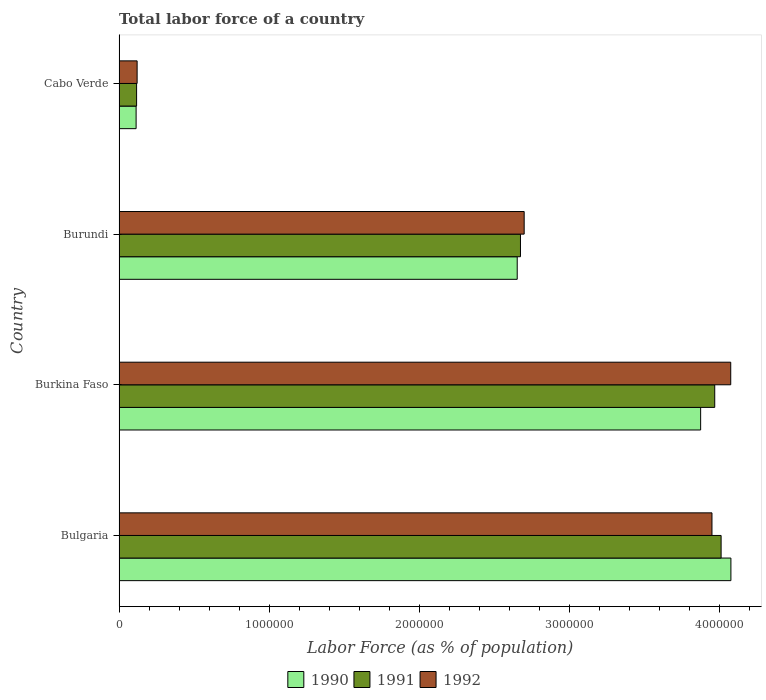How many bars are there on the 4th tick from the top?
Your answer should be compact. 3. How many bars are there on the 4th tick from the bottom?
Give a very brief answer. 3. What is the label of the 1st group of bars from the top?
Ensure brevity in your answer.  Cabo Verde. In how many cases, is the number of bars for a given country not equal to the number of legend labels?
Keep it short and to the point. 0. What is the percentage of labor force in 1991 in Burundi?
Your answer should be compact. 2.68e+06. Across all countries, what is the maximum percentage of labor force in 1991?
Provide a succinct answer. 4.01e+06. Across all countries, what is the minimum percentage of labor force in 1991?
Provide a succinct answer. 1.17e+05. In which country was the percentage of labor force in 1990 minimum?
Give a very brief answer. Cabo Verde. What is the total percentage of labor force in 1992 in the graph?
Keep it short and to the point. 1.08e+07. What is the difference between the percentage of labor force in 1992 in Burkina Faso and that in Burundi?
Your answer should be compact. 1.38e+06. What is the difference between the percentage of labor force in 1990 in Burundi and the percentage of labor force in 1991 in Bulgaria?
Offer a terse response. -1.36e+06. What is the average percentage of labor force in 1992 per country?
Ensure brevity in your answer.  2.71e+06. What is the difference between the percentage of labor force in 1990 and percentage of labor force in 1991 in Bulgaria?
Your answer should be compact. 6.53e+04. In how many countries, is the percentage of labor force in 1990 greater than 3000000 %?
Offer a terse response. 2. What is the ratio of the percentage of labor force in 1992 in Burkina Faso to that in Burundi?
Your answer should be compact. 1.51. What is the difference between the highest and the second highest percentage of labor force in 1992?
Make the answer very short. 1.25e+05. What is the difference between the highest and the lowest percentage of labor force in 1992?
Your answer should be very brief. 3.96e+06. In how many countries, is the percentage of labor force in 1992 greater than the average percentage of labor force in 1992 taken over all countries?
Your answer should be compact. 2. Is the sum of the percentage of labor force in 1991 in Bulgaria and Burundi greater than the maximum percentage of labor force in 1992 across all countries?
Your response must be concise. Yes. What does the 3rd bar from the bottom in Burkina Faso represents?
Offer a very short reply. 1992. How many countries are there in the graph?
Your answer should be very brief. 4. Are the values on the major ticks of X-axis written in scientific E-notation?
Ensure brevity in your answer.  No. Does the graph contain any zero values?
Ensure brevity in your answer.  No. Does the graph contain grids?
Offer a terse response. No. How many legend labels are there?
Your response must be concise. 3. What is the title of the graph?
Make the answer very short. Total labor force of a country. Does "1984" appear as one of the legend labels in the graph?
Keep it short and to the point. No. What is the label or title of the X-axis?
Offer a very short reply. Labor Force (as % of population). What is the Labor Force (as % of population) in 1990 in Bulgaria?
Make the answer very short. 4.08e+06. What is the Labor Force (as % of population) in 1991 in Bulgaria?
Ensure brevity in your answer.  4.01e+06. What is the Labor Force (as % of population) of 1992 in Bulgaria?
Ensure brevity in your answer.  3.95e+06. What is the Labor Force (as % of population) of 1990 in Burkina Faso?
Your answer should be very brief. 3.88e+06. What is the Labor Force (as % of population) in 1991 in Burkina Faso?
Your response must be concise. 3.97e+06. What is the Labor Force (as % of population) in 1992 in Burkina Faso?
Offer a terse response. 4.08e+06. What is the Labor Force (as % of population) of 1990 in Burundi?
Give a very brief answer. 2.65e+06. What is the Labor Force (as % of population) of 1991 in Burundi?
Offer a terse response. 2.68e+06. What is the Labor Force (as % of population) in 1992 in Burundi?
Make the answer very short. 2.70e+06. What is the Labor Force (as % of population) of 1990 in Cabo Verde?
Keep it short and to the point. 1.14e+05. What is the Labor Force (as % of population) in 1991 in Cabo Verde?
Provide a short and direct response. 1.17e+05. What is the Labor Force (as % of population) of 1992 in Cabo Verde?
Offer a terse response. 1.20e+05. Across all countries, what is the maximum Labor Force (as % of population) of 1990?
Provide a succinct answer. 4.08e+06. Across all countries, what is the maximum Labor Force (as % of population) in 1991?
Make the answer very short. 4.01e+06. Across all countries, what is the maximum Labor Force (as % of population) of 1992?
Give a very brief answer. 4.08e+06. Across all countries, what is the minimum Labor Force (as % of population) of 1990?
Offer a very short reply. 1.14e+05. Across all countries, what is the minimum Labor Force (as % of population) in 1991?
Make the answer very short. 1.17e+05. Across all countries, what is the minimum Labor Force (as % of population) of 1992?
Offer a terse response. 1.20e+05. What is the total Labor Force (as % of population) of 1990 in the graph?
Your answer should be compact. 1.07e+07. What is the total Labor Force (as % of population) in 1991 in the graph?
Your response must be concise. 1.08e+07. What is the total Labor Force (as % of population) of 1992 in the graph?
Your answer should be compact. 1.08e+07. What is the difference between the Labor Force (as % of population) in 1990 in Bulgaria and that in Burkina Faso?
Offer a terse response. 2.02e+05. What is the difference between the Labor Force (as % of population) in 1991 in Bulgaria and that in Burkina Faso?
Provide a succinct answer. 4.25e+04. What is the difference between the Labor Force (as % of population) of 1992 in Bulgaria and that in Burkina Faso?
Keep it short and to the point. -1.25e+05. What is the difference between the Labor Force (as % of population) in 1990 in Bulgaria and that in Burundi?
Your answer should be very brief. 1.42e+06. What is the difference between the Labor Force (as % of population) of 1991 in Bulgaria and that in Burundi?
Provide a short and direct response. 1.34e+06. What is the difference between the Labor Force (as % of population) of 1992 in Bulgaria and that in Burundi?
Provide a succinct answer. 1.25e+06. What is the difference between the Labor Force (as % of population) of 1990 in Bulgaria and that in Cabo Verde?
Keep it short and to the point. 3.96e+06. What is the difference between the Labor Force (as % of population) of 1991 in Bulgaria and that in Cabo Verde?
Provide a succinct answer. 3.90e+06. What is the difference between the Labor Force (as % of population) in 1992 in Bulgaria and that in Cabo Verde?
Give a very brief answer. 3.83e+06. What is the difference between the Labor Force (as % of population) of 1990 in Burkina Faso and that in Burundi?
Your answer should be very brief. 1.22e+06. What is the difference between the Labor Force (as % of population) of 1991 in Burkina Faso and that in Burundi?
Make the answer very short. 1.29e+06. What is the difference between the Labor Force (as % of population) in 1992 in Burkina Faso and that in Burundi?
Make the answer very short. 1.38e+06. What is the difference between the Labor Force (as % of population) in 1990 in Burkina Faso and that in Cabo Verde?
Your answer should be compact. 3.76e+06. What is the difference between the Labor Force (as % of population) in 1991 in Burkina Faso and that in Cabo Verde?
Ensure brevity in your answer.  3.85e+06. What is the difference between the Labor Force (as % of population) of 1992 in Burkina Faso and that in Cabo Verde?
Your answer should be compact. 3.96e+06. What is the difference between the Labor Force (as % of population) in 1990 in Burundi and that in Cabo Verde?
Give a very brief answer. 2.54e+06. What is the difference between the Labor Force (as % of population) of 1991 in Burundi and that in Cabo Verde?
Offer a terse response. 2.56e+06. What is the difference between the Labor Force (as % of population) of 1992 in Burundi and that in Cabo Verde?
Make the answer very short. 2.58e+06. What is the difference between the Labor Force (as % of population) of 1990 in Bulgaria and the Labor Force (as % of population) of 1991 in Burkina Faso?
Your answer should be very brief. 1.08e+05. What is the difference between the Labor Force (as % of population) in 1990 in Bulgaria and the Labor Force (as % of population) in 1992 in Burkina Faso?
Provide a short and direct response. 1124. What is the difference between the Labor Force (as % of population) of 1991 in Bulgaria and the Labor Force (as % of population) of 1992 in Burkina Faso?
Ensure brevity in your answer.  -6.42e+04. What is the difference between the Labor Force (as % of population) in 1990 in Bulgaria and the Labor Force (as % of population) in 1991 in Burundi?
Your answer should be very brief. 1.40e+06. What is the difference between the Labor Force (as % of population) of 1990 in Bulgaria and the Labor Force (as % of population) of 1992 in Burundi?
Offer a terse response. 1.38e+06. What is the difference between the Labor Force (as % of population) of 1991 in Bulgaria and the Labor Force (as % of population) of 1992 in Burundi?
Offer a very short reply. 1.31e+06. What is the difference between the Labor Force (as % of population) in 1990 in Bulgaria and the Labor Force (as % of population) in 1991 in Cabo Verde?
Keep it short and to the point. 3.96e+06. What is the difference between the Labor Force (as % of population) of 1990 in Bulgaria and the Labor Force (as % of population) of 1992 in Cabo Verde?
Keep it short and to the point. 3.96e+06. What is the difference between the Labor Force (as % of population) of 1991 in Bulgaria and the Labor Force (as % of population) of 1992 in Cabo Verde?
Keep it short and to the point. 3.89e+06. What is the difference between the Labor Force (as % of population) in 1990 in Burkina Faso and the Labor Force (as % of population) in 1991 in Burundi?
Give a very brief answer. 1.20e+06. What is the difference between the Labor Force (as % of population) of 1990 in Burkina Faso and the Labor Force (as % of population) of 1992 in Burundi?
Your answer should be compact. 1.18e+06. What is the difference between the Labor Force (as % of population) of 1991 in Burkina Faso and the Labor Force (as % of population) of 1992 in Burundi?
Your answer should be compact. 1.27e+06. What is the difference between the Labor Force (as % of population) in 1990 in Burkina Faso and the Labor Force (as % of population) in 1991 in Cabo Verde?
Provide a succinct answer. 3.76e+06. What is the difference between the Labor Force (as % of population) in 1990 in Burkina Faso and the Labor Force (as % of population) in 1992 in Cabo Verde?
Ensure brevity in your answer.  3.76e+06. What is the difference between the Labor Force (as % of population) of 1991 in Burkina Faso and the Labor Force (as % of population) of 1992 in Cabo Verde?
Ensure brevity in your answer.  3.85e+06. What is the difference between the Labor Force (as % of population) in 1990 in Burundi and the Labor Force (as % of population) in 1991 in Cabo Verde?
Your response must be concise. 2.54e+06. What is the difference between the Labor Force (as % of population) of 1990 in Burundi and the Labor Force (as % of population) of 1992 in Cabo Verde?
Make the answer very short. 2.53e+06. What is the difference between the Labor Force (as % of population) in 1991 in Burundi and the Labor Force (as % of population) in 1992 in Cabo Verde?
Provide a short and direct response. 2.55e+06. What is the average Labor Force (as % of population) of 1990 per country?
Ensure brevity in your answer.  2.68e+06. What is the average Labor Force (as % of population) of 1991 per country?
Your response must be concise. 2.69e+06. What is the average Labor Force (as % of population) in 1992 per country?
Your answer should be very brief. 2.71e+06. What is the difference between the Labor Force (as % of population) of 1990 and Labor Force (as % of population) of 1991 in Bulgaria?
Your answer should be compact. 6.53e+04. What is the difference between the Labor Force (as % of population) in 1990 and Labor Force (as % of population) in 1992 in Bulgaria?
Offer a terse response. 1.26e+05. What is the difference between the Labor Force (as % of population) of 1991 and Labor Force (as % of population) of 1992 in Bulgaria?
Your answer should be very brief. 6.08e+04. What is the difference between the Labor Force (as % of population) in 1990 and Labor Force (as % of population) in 1991 in Burkina Faso?
Make the answer very short. -9.39e+04. What is the difference between the Labor Force (as % of population) of 1990 and Labor Force (as % of population) of 1992 in Burkina Faso?
Ensure brevity in your answer.  -2.01e+05. What is the difference between the Labor Force (as % of population) of 1991 and Labor Force (as % of population) of 1992 in Burkina Faso?
Offer a terse response. -1.07e+05. What is the difference between the Labor Force (as % of population) of 1990 and Labor Force (as % of population) of 1991 in Burundi?
Offer a terse response. -2.17e+04. What is the difference between the Labor Force (as % of population) in 1990 and Labor Force (as % of population) in 1992 in Burundi?
Give a very brief answer. -4.64e+04. What is the difference between the Labor Force (as % of population) in 1991 and Labor Force (as % of population) in 1992 in Burundi?
Provide a short and direct response. -2.47e+04. What is the difference between the Labor Force (as % of population) of 1990 and Labor Force (as % of population) of 1991 in Cabo Verde?
Keep it short and to the point. -3171. What is the difference between the Labor Force (as % of population) of 1990 and Labor Force (as % of population) of 1992 in Cabo Verde?
Keep it short and to the point. -6675. What is the difference between the Labor Force (as % of population) in 1991 and Labor Force (as % of population) in 1992 in Cabo Verde?
Your answer should be very brief. -3504. What is the ratio of the Labor Force (as % of population) of 1990 in Bulgaria to that in Burkina Faso?
Your answer should be compact. 1.05. What is the ratio of the Labor Force (as % of population) of 1991 in Bulgaria to that in Burkina Faso?
Keep it short and to the point. 1.01. What is the ratio of the Labor Force (as % of population) in 1992 in Bulgaria to that in Burkina Faso?
Provide a short and direct response. 0.97. What is the ratio of the Labor Force (as % of population) in 1990 in Bulgaria to that in Burundi?
Offer a very short reply. 1.54. What is the ratio of the Labor Force (as % of population) in 1991 in Bulgaria to that in Burundi?
Make the answer very short. 1.5. What is the ratio of the Labor Force (as % of population) in 1992 in Bulgaria to that in Burundi?
Make the answer very short. 1.46. What is the ratio of the Labor Force (as % of population) in 1990 in Bulgaria to that in Cabo Verde?
Ensure brevity in your answer.  35.85. What is the ratio of the Labor Force (as % of population) in 1991 in Bulgaria to that in Cabo Verde?
Give a very brief answer. 34.32. What is the ratio of the Labor Force (as % of population) of 1992 in Bulgaria to that in Cabo Verde?
Provide a short and direct response. 32.82. What is the ratio of the Labor Force (as % of population) of 1990 in Burkina Faso to that in Burundi?
Ensure brevity in your answer.  1.46. What is the ratio of the Labor Force (as % of population) in 1991 in Burkina Faso to that in Burundi?
Provide a short and direct response. 1.48. What is the ratio of the Labor Force (as % of population) of 1992 in Burkina Faso to that in Burundi?
Keep it short and to the point. 1.51. What is the ratio of the Labor Force (as % of population) in 1990 in Burkina Faso to that in Cabo Verde?
Your answer should be very brief. 34.08. What is the ratio of the Labor Force (as % of population) of 1991 in Burkina Faso to that in Cabo Verde?
Your answer should be very brief. 33.96. What is the ratio of the Labor Force (as % of population) of 1992 in Burkina Faso to that in Cabo Verde?
Give a very brief answer. 33.86. What is the ratio of the Labor Force (as % of population) of 1990 in Burundi to that in Cabo Verde?
Keep it short and to the point. 23.33. What is the ratio of the Labor Force (as % of population) in 1991 in Burundi to that in Cabo Verde?
Your answer should be compact. 22.89. What is the ratio of the Labor Force (as % of population) in 1992 in Burundi to that in Cabo Verde?
Keep it short and to the point. 22.42. What is the difference between the highest and the second highest Labor Force (as % of population) of 1990?
Offer a terse response. 2.02e+05. What is the difference between the highest and the second highest Labor Force (as % of population) of 1991?
Give a very brief answer. 4.25e+04. What is the difference between the highest and the second highest Labor Force (as % of population) of 1992?
Offer a very short reply. 1.25e+05. What is the difference between the highest and the lowest Labor Force (as % of population) of 1990?
Your answer should be compact. 3.96e+06. What is the difference between the highest and the lowest Labor Force (as % of population) in 1991?
Provide a succinct answer. 3.90e+06. What is the difference between the highest and the lowest Labor Force (as % of population) in 1992?
Provide a short and direct response. 3.96e+06. 